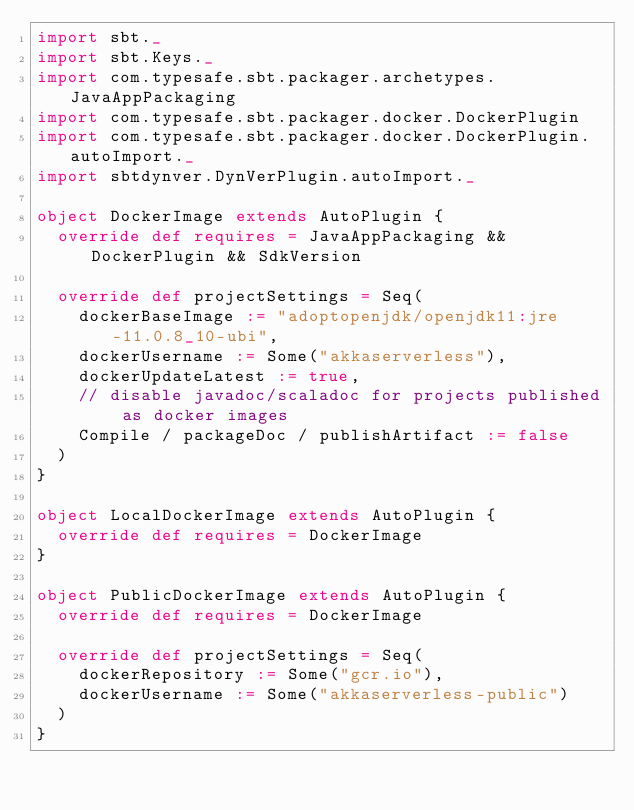<code> <loc_0><loc_0><loc_500><loc_500><_Scala_>import sbt._
import sbt.Keys._
import com.typesafe.sbt.packager.archetypes.JavaAppPackaging
import com.typesafe.sbt.packager.docker.DockerPlugin
import com.typesafe.sbt.packager.docker.DockerPlugin.autoImport._
import sbtdynver.DynVerPlugin.autoImport._

object DockerImage extends AutoPlugin {
  override def requires = JavaAppPackaging && DockerPlugin && SdkVersion

  override def projectSettings = Seq(
    dockerBaseImage := "adoptopenjdk/openjdk11:jre-11.0.8_10-ubi",
    dockerUsername := Some("akkaserverless"),
    dockerUpdateLatest := true,
    // disable javadoc/scaladoc for projects published as docker images
    Compile / packageDoc / publishArtifact := false
  )
}

object LocalDockerImage extends AutoPlugin {
  override def requires = DockerImage
}

object PublicDockerImage extends AutoPlugin {
  override def requires = DockerImage

  override def projectSettings = Seq(
    dockerRepository := Some("gcr.io"),
    dockerUsername := Some("akkaserverless-public")
  )
}
</code> 